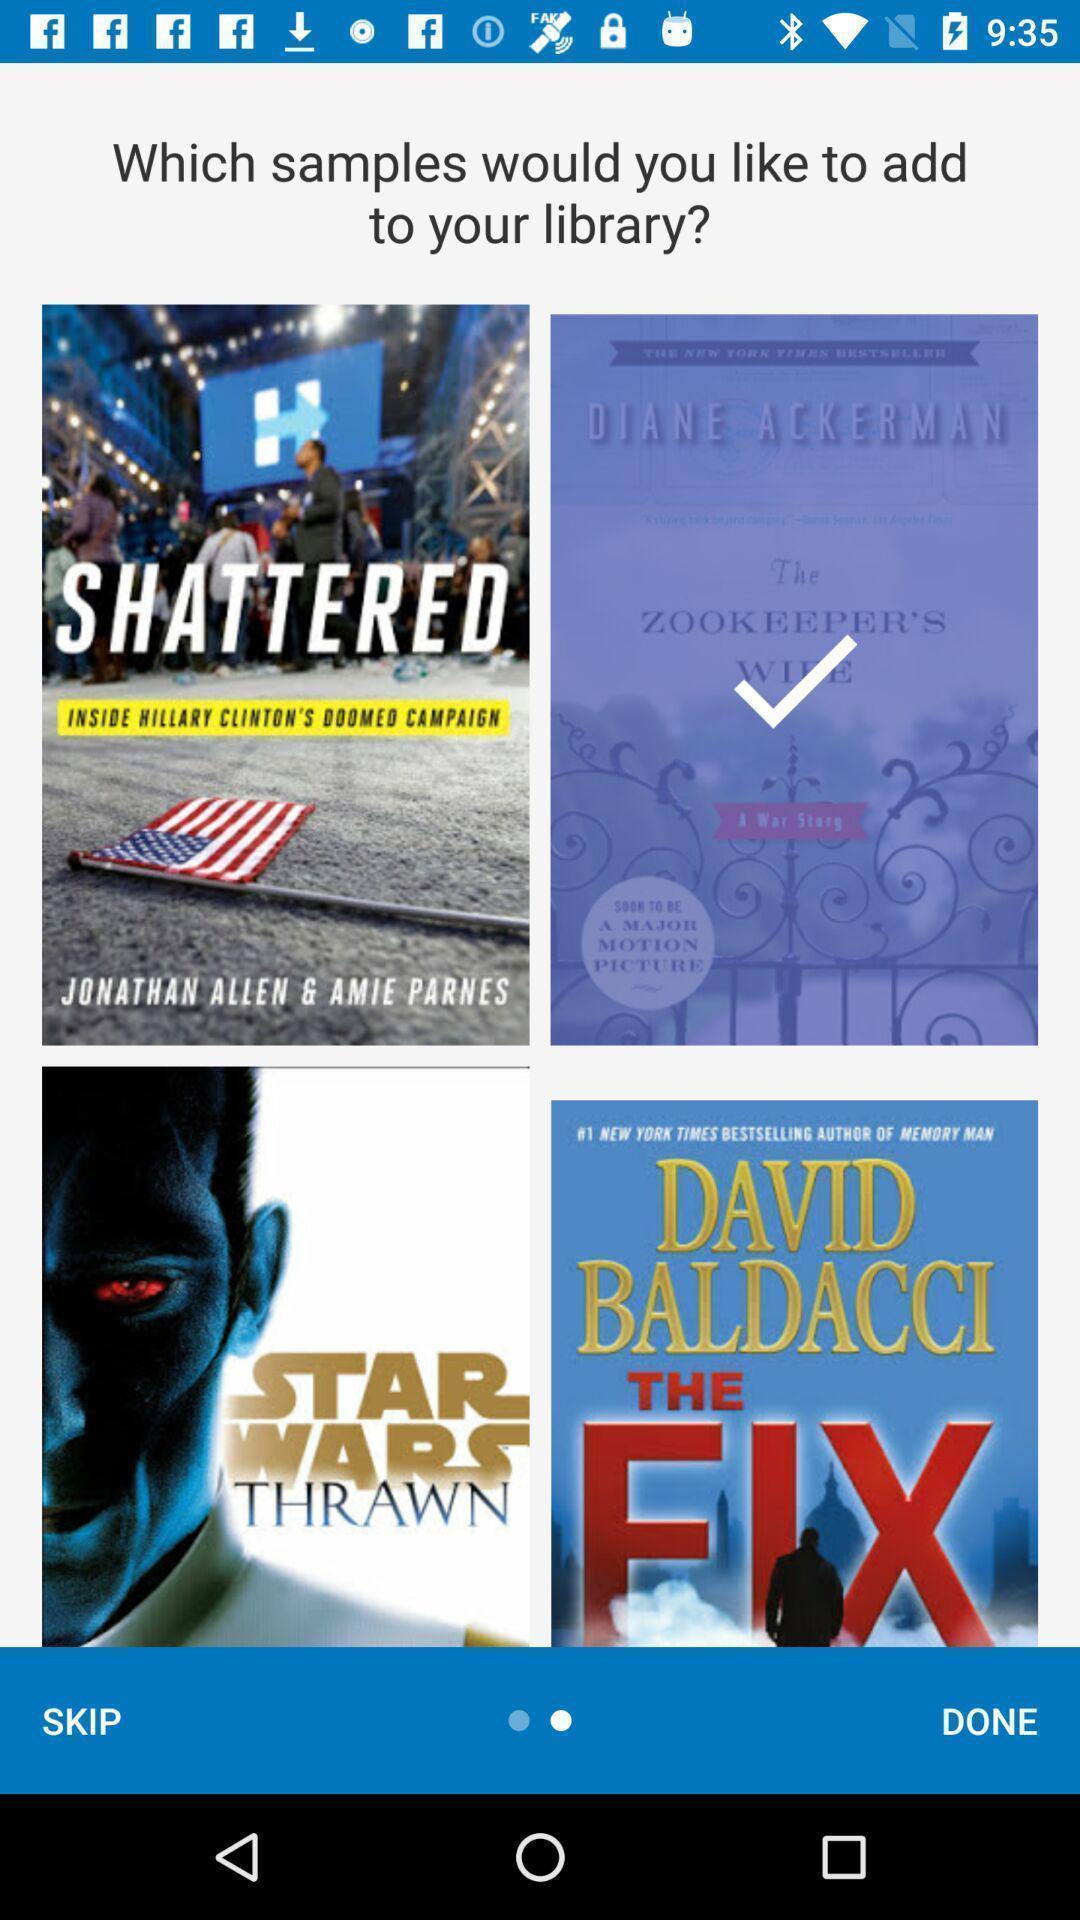Give me a summary of this screen capture. Welcome page of a e-books app. 